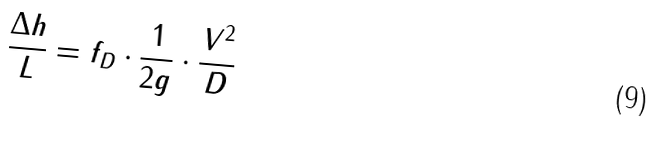Convert formula to latex. <formula><loc_0><loc_0><loc_500><loc_500>\frac { \Delta h } { L } = f _ { D } \cdot \frac { 1 } { 2 g } \cdot \frac { V ^ { 2 } } { D }</formula> 